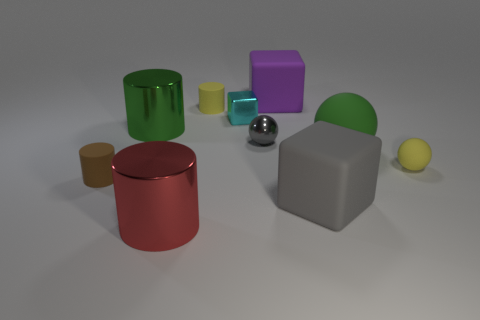There is a small yellow matte object that is to the right of the yellow thing that is on the left side of the small shiny sphere; are there any big metallic things that are behind it?
Your response must be concise. Yes. There is a gray thing that is the same shape as the cyan shiny object; what is it made of?
Your answer should be compact. Rubber. How many cylinders are large green metal objects or green matte things?
Offer a terse response. 1. Is the size of the rubber block behind the yellow cylinder the same as the green object that is to the right of the purple matte object?
Offer a terse response. Yes. There is a large green ball in front of the yellow thing that is on the left side of the big green ball; what is it made of?
Your response must be concise. Rubber. Is the number of green things to the right of the gray cube less than the number of purple matte blocks?
Offer a terse response. No. What shape is the purple object that is the same material as the gray cube?
Your answer should be compact. Cube. How many other objects are there of the same shape as the red metallic object?
Make the answer very short. 3. How many purple things are either big balls or tiny objects?
Make the answer very short. 0. Is the shape of the red metal object the same as the small brown rubber thing?
Keep it short and to the point. Yes. 